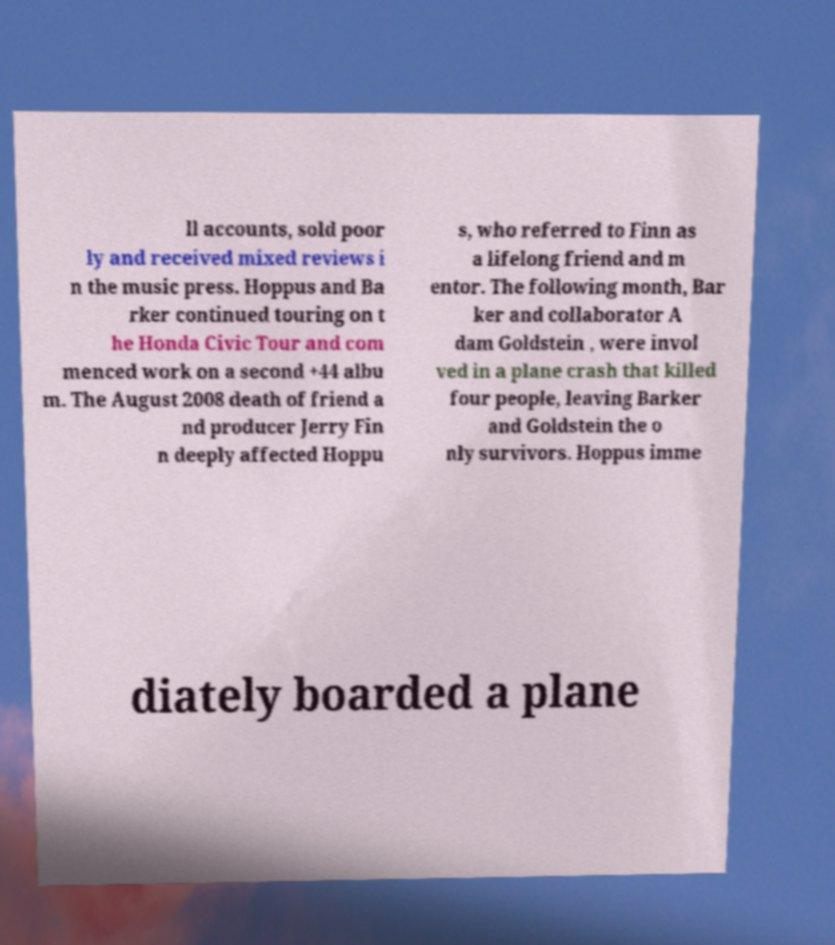Can you accurately transcribe the text from the provided image for me? ll accounts, sold poor ly and received mixed reviews i n the music press. Hoppus and Ba rker continued touring on t he Honda Civic Tour and com menced work on a second +44 albu m. The August 2008 death of friend a nd producer Jerry Fin n deeply affected Hoppu s, who referred to Finn as a lifelong friend and m entor. The following month, Bar ker and collaborator A dam Goldstein , were invol ved in a plane crash that killed four people, leaving Barker and Goldstein the o nly survivors. Hoppus imme diately boarded a plane 